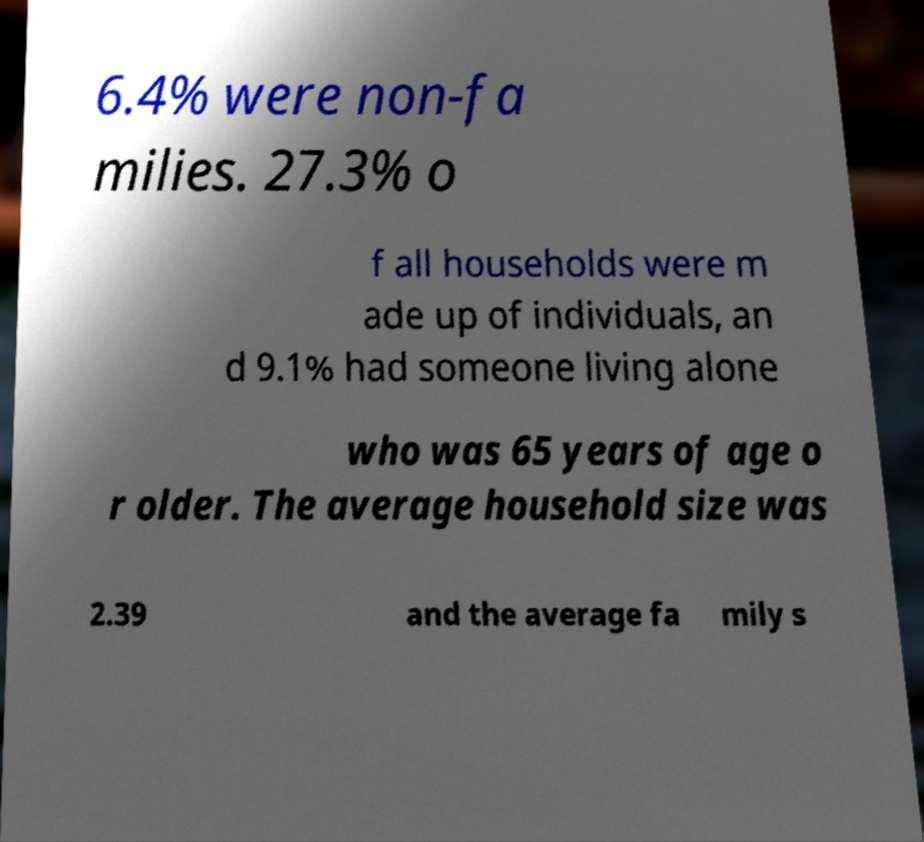Please read and relay the text visible in this image. What does it say? 6.4% were non-fa milies. 27.3% o f all households were m ade up of individuals, an d 9.1% had someone living alone who was 65 years of age o r older. The average household size was 2.39 and the average fa mily s 